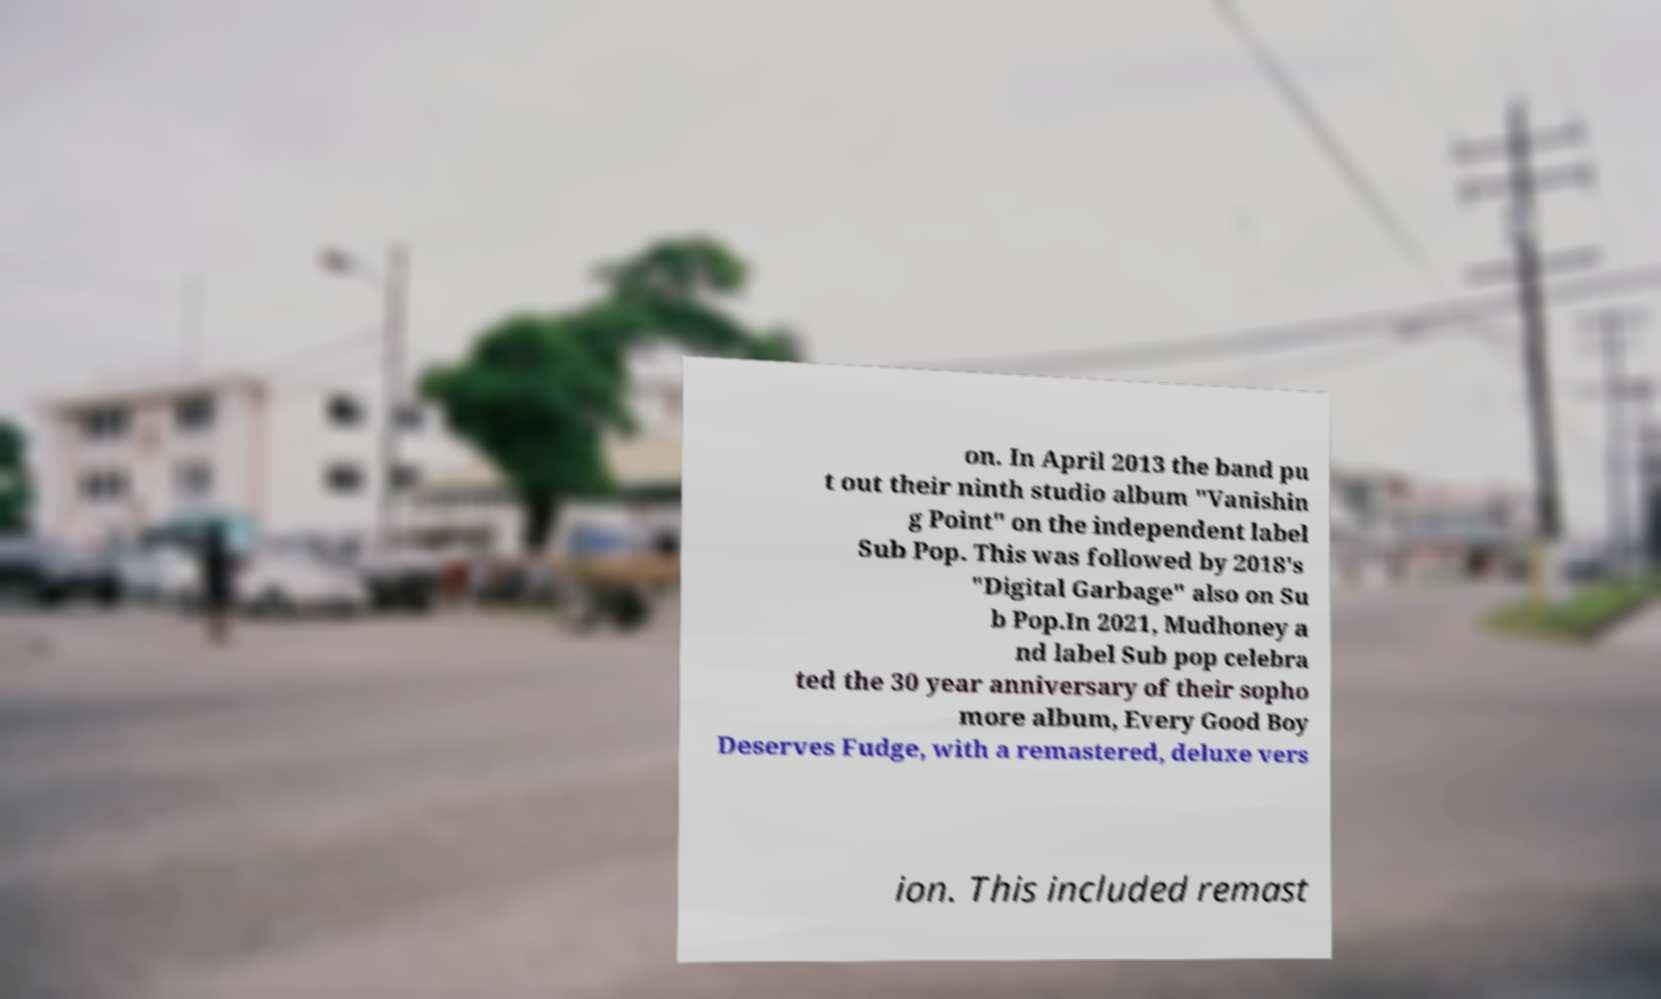Please read and relay the text visible in this image. What does it say? on. In April 2013 the band pu t out their ninth studio album "Vanishin g Point" on the independent label Sub Pop. This was followed by 2018's "Digital Garbage" also on Su b Pop.In 2021, Mudhoney a nd label Sub pop celebra ted the 30 year anniversary of their sopho more album, Every Good Boy Deserves Fudge, with a remastered, deluxe vers ion. This included remast 